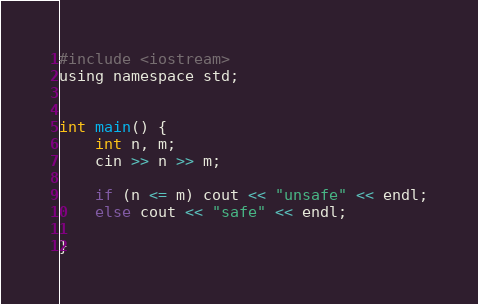<code> <loc_0><loc_0><loc_500><loc_500><_C_>#include <iostream>
using namespace std;


int main() {
    int n, m;
    cin >> n >> m;
    
    if (n <= m) cout << "unsafe" << endl;
    else cout << "safe" << endl;

}</code> 